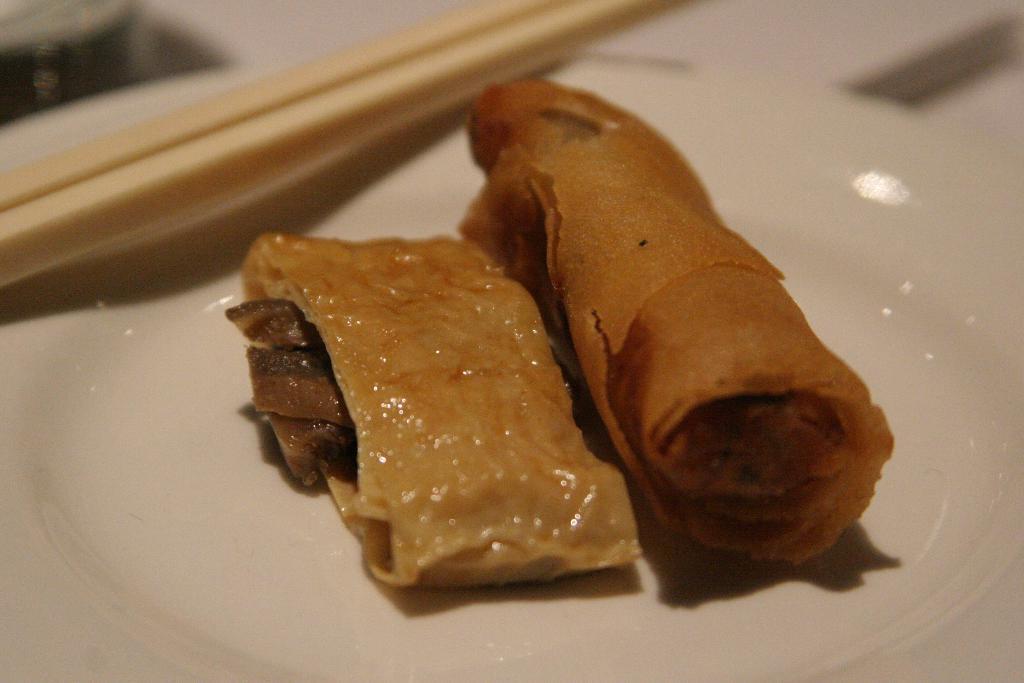Could you give a brief overview of what you see in this image? In this image i can see a white plate which is filled of food item and beside i can see a tooth picks. 